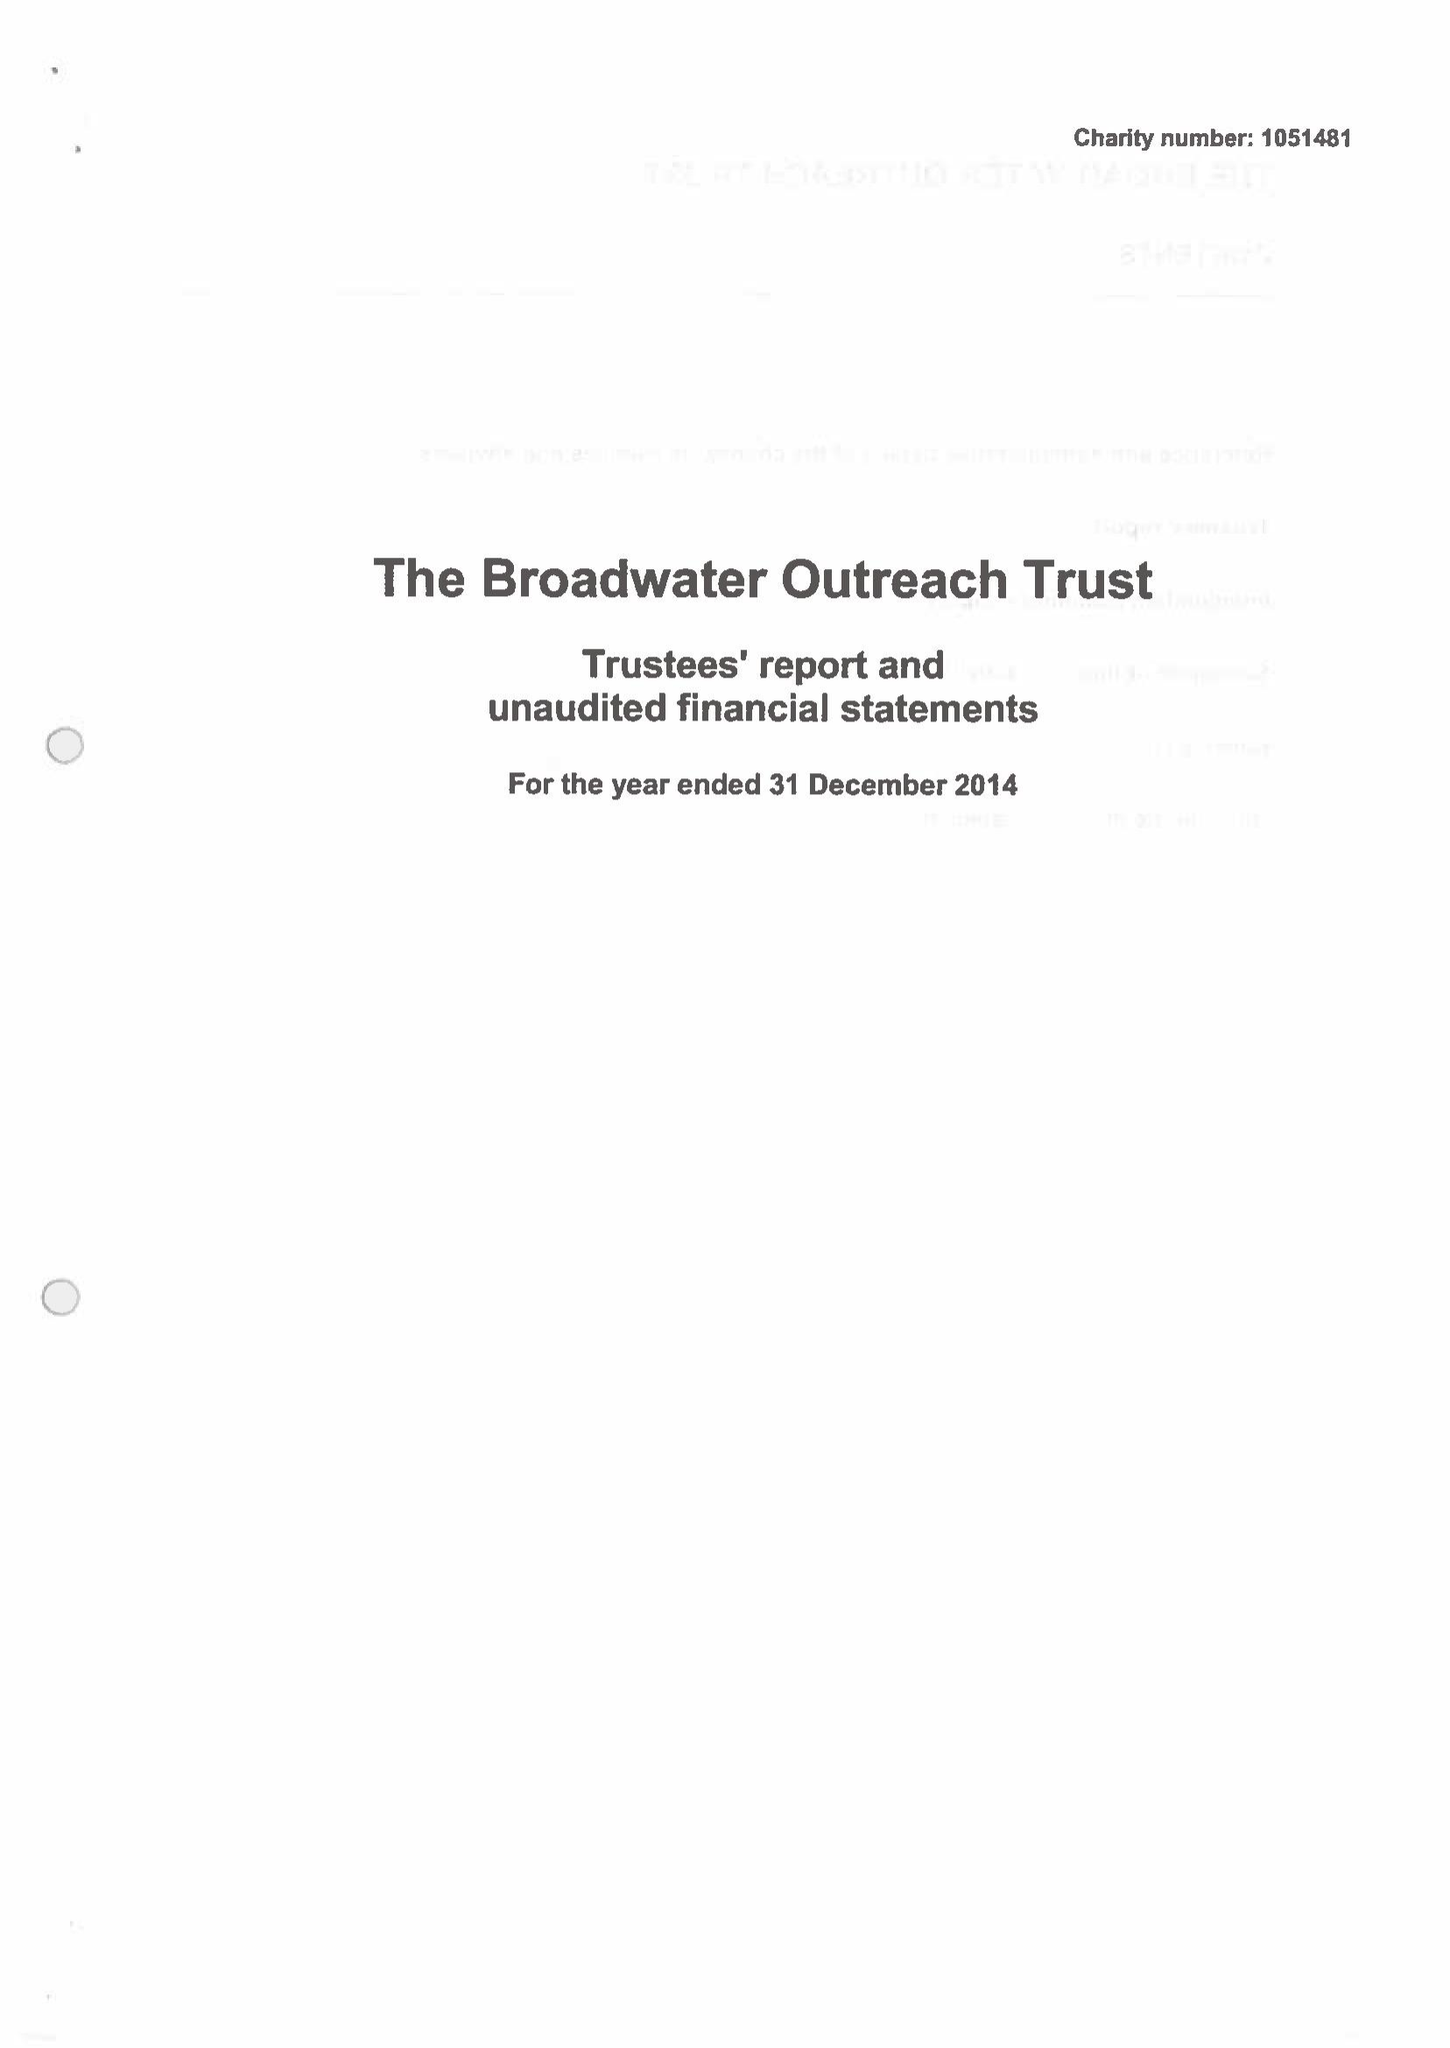What is the value for the address__street_line?
Answer the question using a single word or phrase. 117 BROADWATER ROAD 